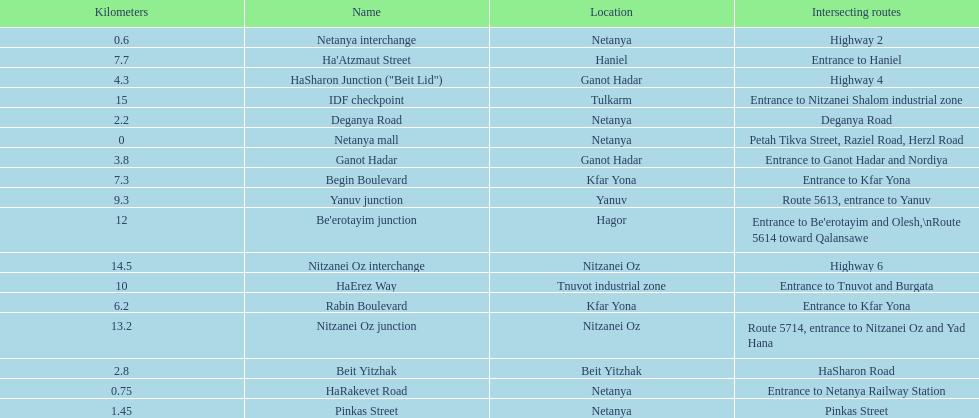After you complete deganya road, what portion comes next? Beit Yitzhak. 